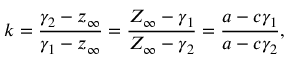Convert formula to latex. <formula><loc_0><loc_0><loc_500><loc_500>k = { \frac { \gamma _ { 2 } - z _ { \infty } } { \gamma _ { 1 } - z _ { \infty } } } = { \frac { Z _ { \infty } - \gamma _ { 1 } } { Z _ { \infty } - \gamma _ { 2 } } } = { \frac { a - c \gamma _ { 1 } } { a - c \gamma _ { 2 } } } ,</formula> 